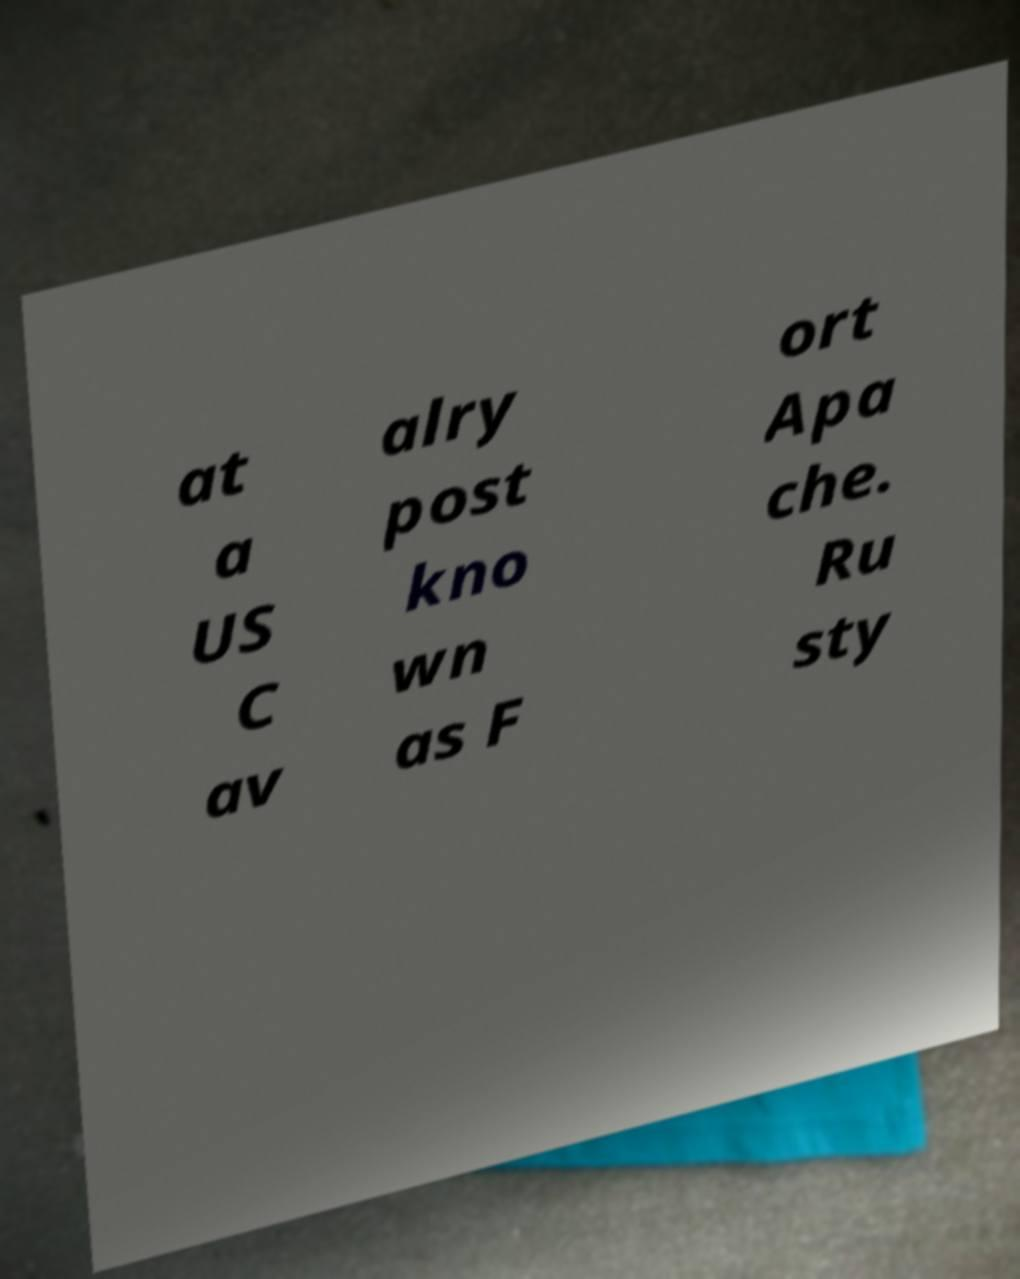Could you extract and type out the text from this image? at a US C av alry post kno wn as F ort Apa che. Ru sty 